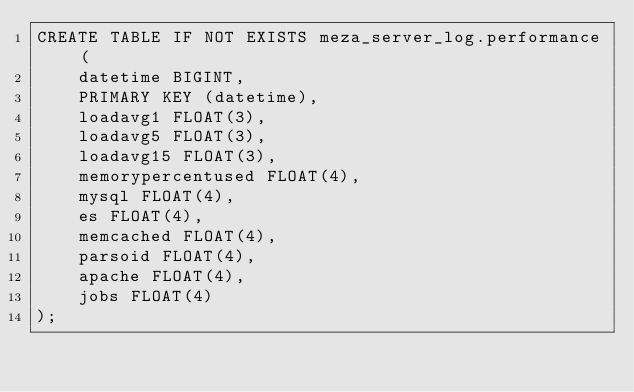<code> <loc_0><loc_0><loc_500><loc_500><_SQL_>CREATE TABLE IF NOT EXISTS meza_server_log.performance (
	datetime BIGINT,
	PRIMARY KEY (datetime),
	loadavg1 FLOAT(3),
	loadavg5 FLOAT(3),
	loadavg15 FLOAT(3),
	memorypercentused FLOAT(4),
	mysql FLOAT(4),
	es FLOAT(4),
	memcached FLOAT(4),
	parsoid FLOAT(4),
	apache FLOAT(4),
	jobs FLOAT(4)
);
</code> 